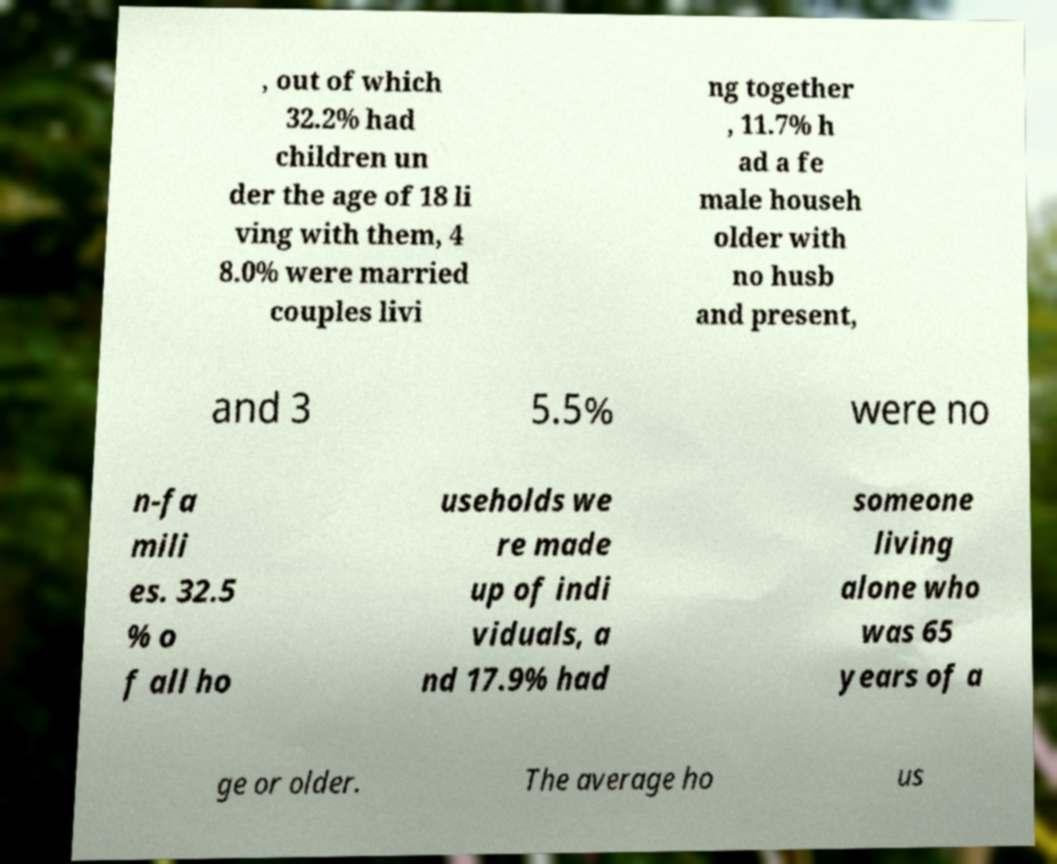What messages or text are displayed in this image? I need them in a readable, typed format. , out of which 32.2% had children un der the age of 18 li ving with them, 4 8.0% were married couples livi ng together , 11.7% h ad a fe male househ older with no husb and present, and 3 5.5% were no n-fa mili es. 32.5 % o f all ho useholds we re made up of indi viduals, a nd 17.9% had someone living alone who was 65 years of a ge or older. The average ho us 